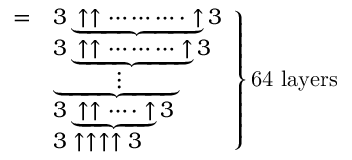Convert formula to latex. <formula><loc_0><loc_0><loc_500><loc_500>{ \begin{array} { l l } { = } & { 3 \underbrace { \uparrow \uparrow \cdots \cdots \cdots \cdot \uparrow } 3 } \\ & { 3 \underbrace { \uparrow \uparrow \cdots \cdots \cdots \uparrow } 3 } \\ & { \underbrace { \quad \, \vdots \quad \, } } \\ & { 3 \underbrace { \uparrow \uparrow \cdots \cdot \uparrow } 3 } \\ & { 3 \uparrow \uparrow \uparrow \uparrow 3 } \end{array} } \right \} { 6 4 l a y e r s }</formula> 